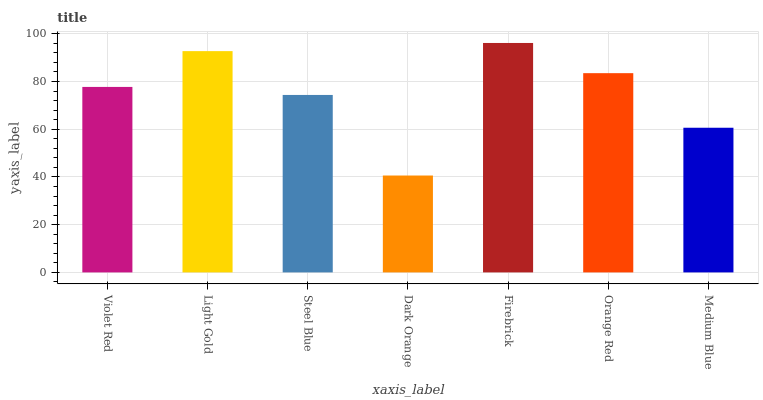Is Dark Orange the minimum?
Answer yes or no. Yes. Is Firebrick the maximum?
Answer yes or no. Yes. Is Light Gold the minimum?
Answer yes or no. No. Is Light Gold the maximum?
Answer yes or no. No. Is Light Gold greater than Violet Red?
Answer yes or no. Yes. Is Violet Red less than Light Gold?
Answer yes or no. Yes. Is Violet Red greater than Light Gold?
Answer yes or no. No. Is Light Gold less than Violet Red?
Answer yes or no. No. Is Violet Red the high median?
Answer yes or no. Yes. Is Violet Red the low median?
Answer yes or no. Yes. Is Light Gold the high median?
Answer yes or no. No. Is Steel Blue the low median?
Answer yes or no. No. 